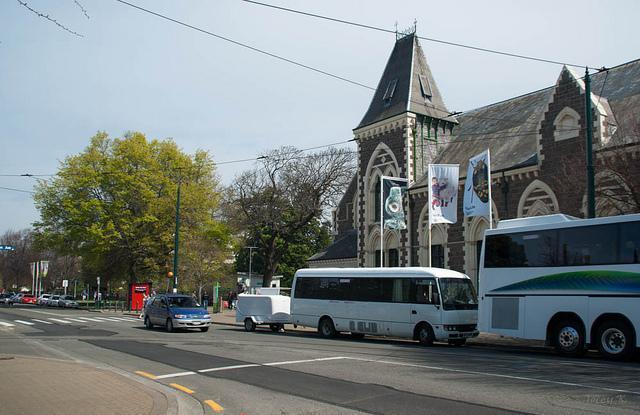What are these banners promoting?
Select the accurate response from the four choices given to answer the question.
Options: Dance halls, museums, open houses, church. Museums. 